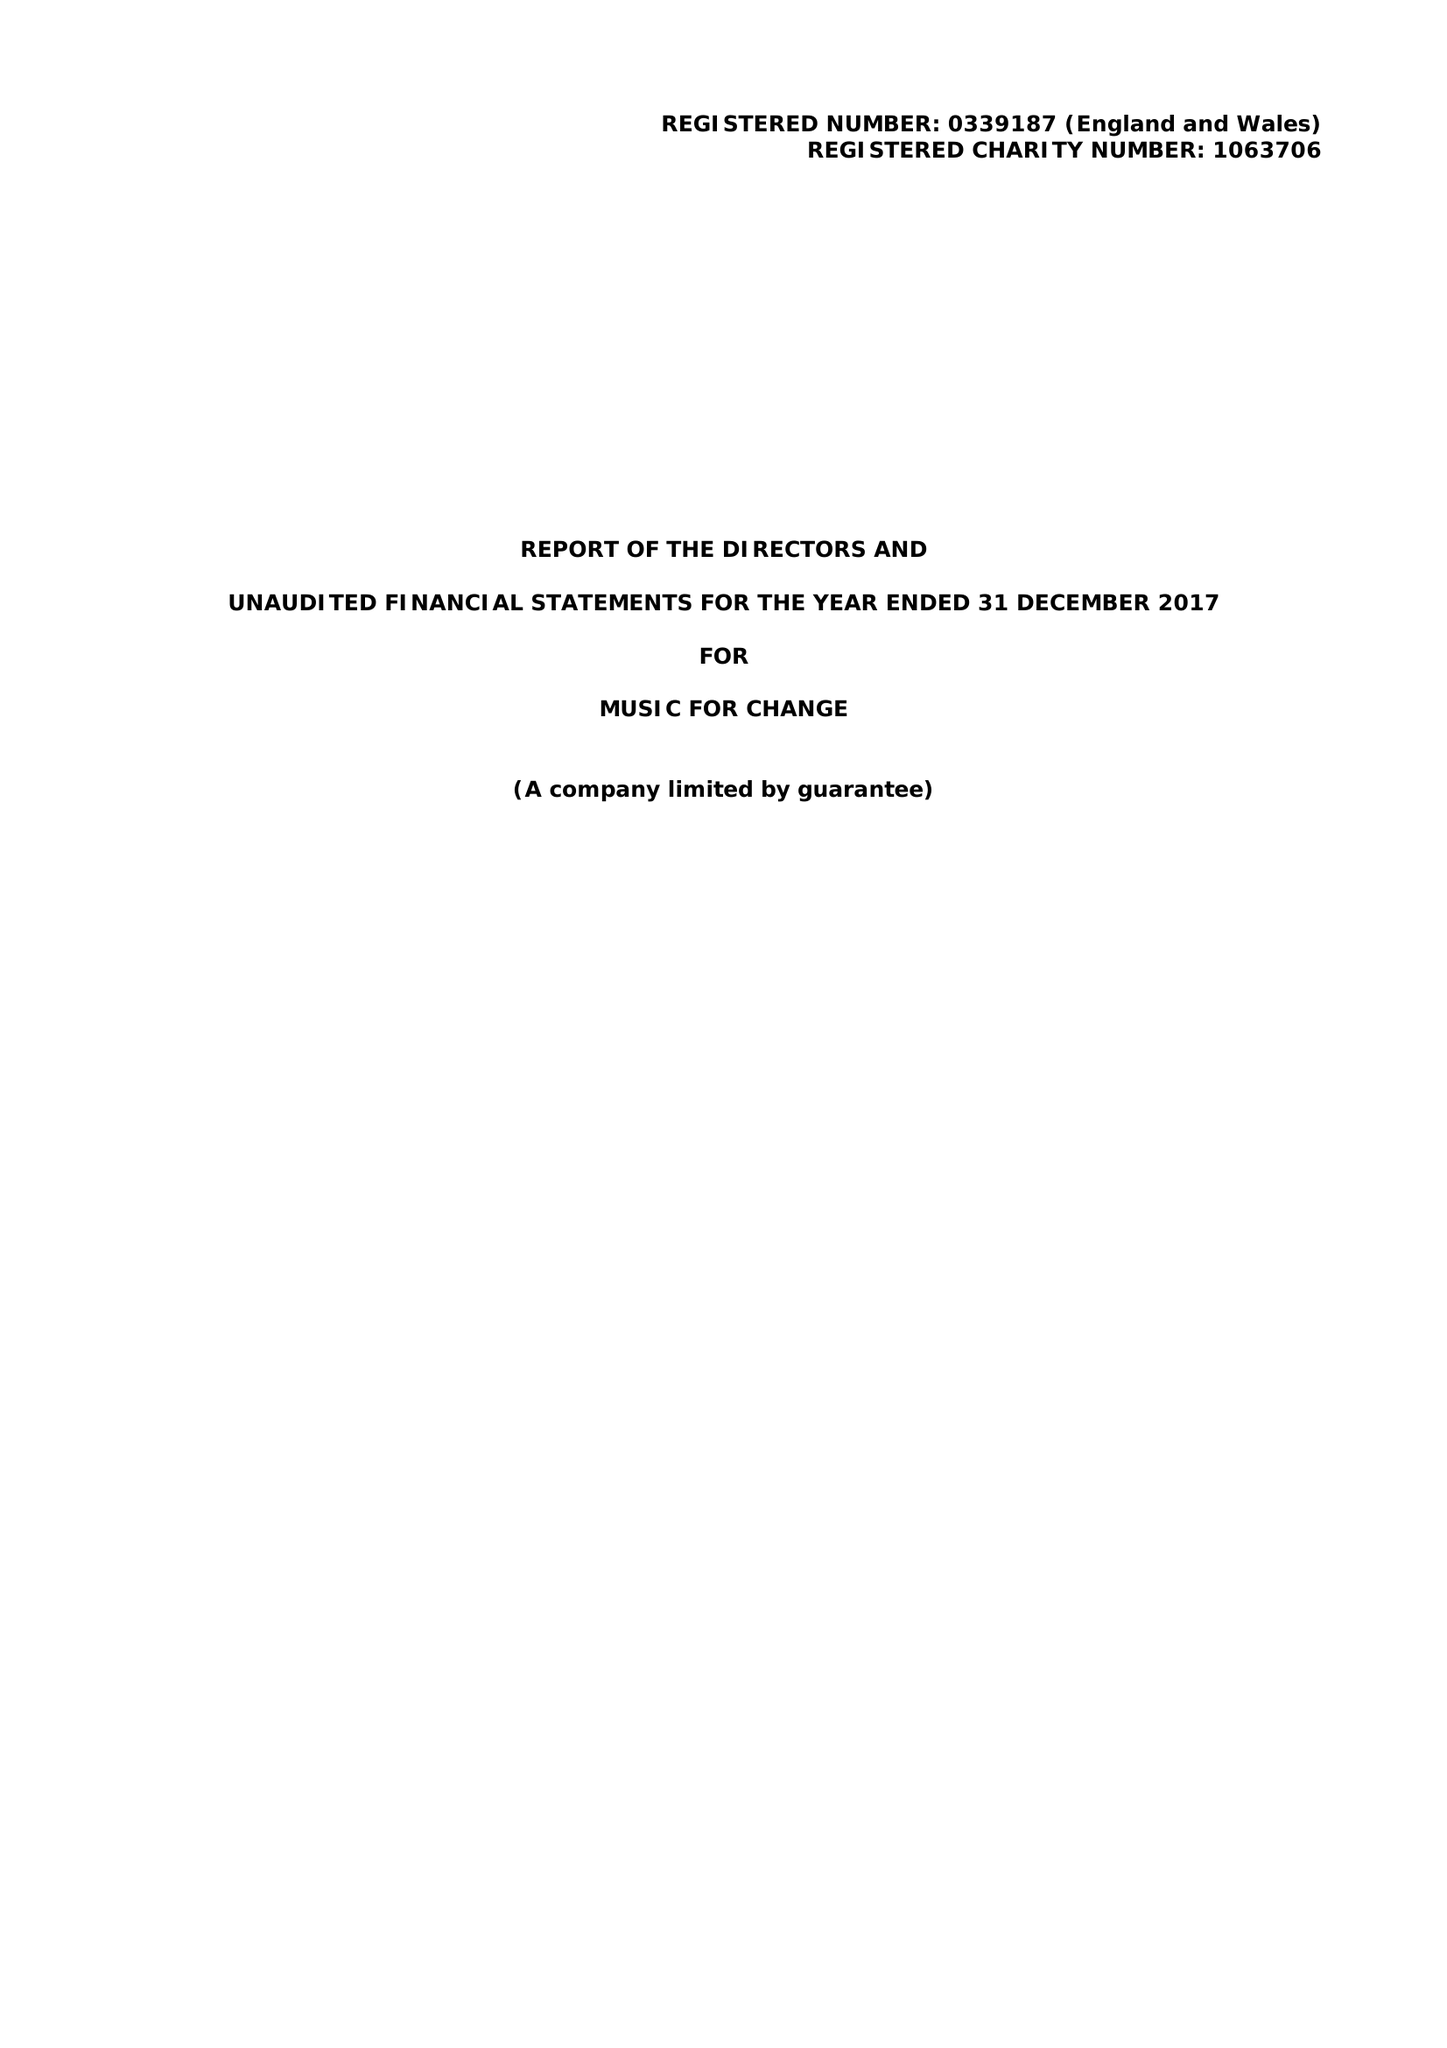What is the value for the spending_annually_in_british_pounds?
Answer the question using a single word or phrase. 167815.00 